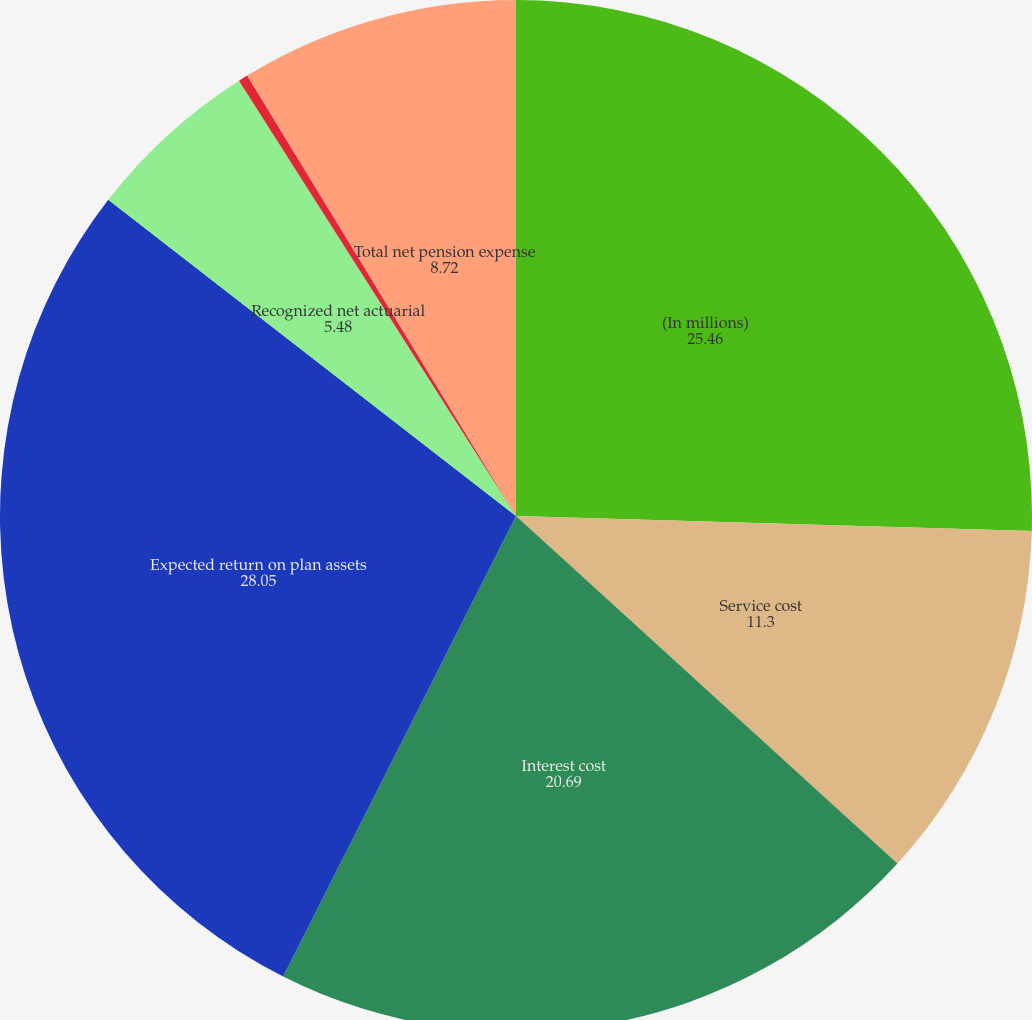Convert chart to OTSL. <chart><loc_0><loc_0><loc_500><loc_500><pie_chart><fcel>(In millions)<fcel>Service cost<fcel>Interest cost<fcel>Expected return on plan assets<fcel>Recognized net actuarial<fcel>Amortization of prior service<fcel>Total net pension expense<nl><fcel>25.46%<fcel>11.3%<fcel>20.69%<fcel>28.05%<fcel>5.48%<fcel>0.3%<fcel>8.72%<nl></chart> 